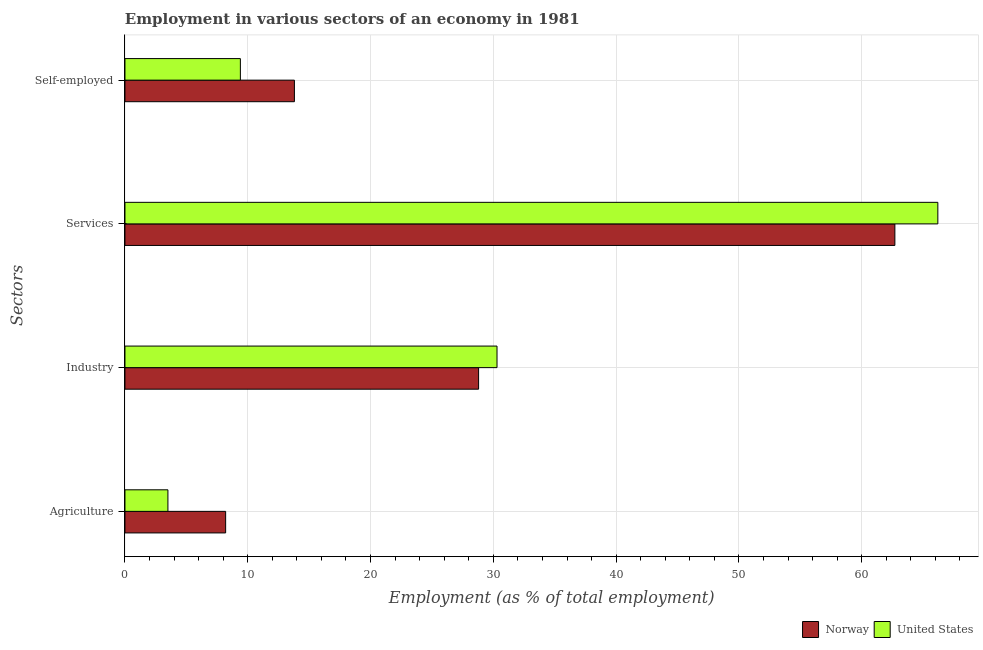How many different coloured bars are there?
Offer a terse response. 2. How many groups of bars are there?
Keep it short and to the point. 4. What is the label of the 4th group of bars from the top?
Keep it short and to the point. Agriculture. What is the percentage of workers in services in United States?
Give a very brief answer. 66.2. Across all countries, what is the maximum percentage of workers in services?
Keep it short and to the point. 66.2. Across all countries, what is the minimum percentage of workers in industry?
Give a very brief answer. 28.8. In which country was the percentage of workers in services minimum?
Offer a terse response. Norway. What is the total percentage of workers in industry in the graph?
Provide a short and direct response. 59.1. What is the difference between the percentage of self employed workers in United States and that in Norway?
Your answer should be compact. -4.4. What is the difference between the percentage of workers in industry in Norway and the percentage of self employed workers in United States?
Provide a short and direct response. 19.4. What is the average percentage of workers in agriculture per country?
Your response must be concise. 5.85. What is the difference between the percentage of self employed workers and percentage of workers in agriculture in Norway?
Keep it short and to the point. 5.6. In how many countries, is the percentage of workers in services greater than 6 %?
Offer a terse response. 2. What is the ratio of the percentage of workers in services in Norway to that in United States?
Make the answer very short. 0.95. Is the difference between the percentage of workers in services in Norway and United States greater than the difference between the percentage of workers in agriculture in Norway and United States?
Keep it short and to the point. No. What is the difference between the highest and the second highest percentage of self employed workers?
Offer a terse response. 4.4. Is it the case that in every country, the sum of the percentage of workers in agriculture and percentage of self employed workers is greater than the sum of percentage of workers in industry and percentage of workers in services?
Provide a succinct answer. Yes. Are all the bars in the graph horizontal?
Your response must be concise. Yes. How many countries are there in the graph?
Your answer should be very brief. 2. What is the difference between two consecutive major ticks on the X-axis?
Ensure brevity in your answer.  10. Are the values on the major ticks of X-axis written in scientific E-notation?
Ensure brevity in your answer.  No. Does the graph contain grids?
Ensure brevity in your answer.  Yes. How are the legend labels stacked?
Your response must be concise. Horizontal. What is the title of the graph?
Provide a short and direct response. Employment in various sectors of an economy in 1981. Does "Mauritania" appear as one of the legend labels in the graph?
Keep it short and to the point. No. What is the label or title of the X-axis?
Make the answer very short. Employment (as % of total employment). What is the label or title of the Y-axis?
Give a very brief answer. Sectors. What is the Employment (as % of total employment) of Norway in Agriculture?
Give a very brief answer. 8.2. What is the Employment (as % of total employment) of Norway in Industry?
Your response must be concise. 28.8. What is the Employment (as % of total employment) of United States in Industry?
Your answer should be compact. 30.3. What is the Employment (as % of total employment) of Norway in Services?
Offer a terse response. 62.7. What is the Employment (as % of total employment) of United States in Services?
Make the answer very short. 66.2. What is the Employment (as % of total employment) in Norway in Self-employed?
Give a very brief answer. 13.8. What is the Employment (as % of total employment) in United States in Self-employed?
Give a very brief answer. 9.4. Across all Sectors, what is the maximum Employment (as % of total employment) in Norway?
Make the answer very short. 62.7. Across all Sectors, what is the maximum Employment (as % of total employment) in United States?
Your answer should be compact. 66.2. Across all Sectors, what is the minimum Employment (as % of total employment) of Norway?
Your response must be concise. 8.2. What is the total Employment (as % of total employment) in Norway in the graph?
Your answer should be very brief. 113.5. What is the total Employment (as % of total employment) of United States in the graph?
Offer a very short reply. 109.4. What is the difference between the Employment (as % of total employment) in Norway in Agriculture and that in Industry?
Ensure brevity in your answer.  -20.6. What is the difference between the Employment (as % of total employment) of United States in Agriculture and that in Industry?
Make the answer very short. -26.8. What is the difference between the Employment (as % of total employment) of Norway in Agriculture and that in Services?
Your response must be concise. -54.5. What is the difference between the Employment (as % of total employment) in United States in Agriculture and that in Services?
Make the answer very short. -62.7. What is the difference between the Employment (as % of total employment) in United States in Agriculture and that in Self-employed?
Provide a succinct answer. -5.9. What is the difference between the Employment (as % of total employment) of Norway in Industry and that in Services?
Make the answer very short. -33.9. What is the difference between the Employment (as % of total employment) in United States in Industry and that in Services?
Your answer should be compact. -35.9. What is the difference between the Employment (as % of total employment) in Norway in Industry and that in Self-employed?
Offer a very short reply. 15. What is the difference between the Employment (as % of total employment) in United States in Industry and that in Self-employed?
Ensure brevity in your answer.  20.9. What is the difference between the Employment (as % of total employment) of Norway in Services and that in Self-employed?
Keep it short and to the point. 48.9. What is the difference between the Employment (as % of total employment) in United States in Services and that in Self-employed?
Keep it short and to the point. 56.8. What is the difference between the Employment (as % of total employment) in Norway in Agriculture and the Employment (as % of total employment) in United States in Industry?
Provide a succinct answer. -22.1. What is the difference between the Employment (as % of total employment) of Norway in Agriculture and the Employment (as % of total employment) of United States in Services?
Your response must be concise. -58. What is the difference between the Employment (as % of total employment) of Norway in Industry and the Employment (as % of total employment) of United States in Services?
Your answer should be compact. -37.4. What is the difference between the Employment (as % of total employment) in Norway in Industry and the Employment (as % of total employment) in United States in Self-employed?
Provide a short and direct response. 19.4. What is the difference between the Employment (as % of total employment) in Norway in Services and the Employment (as % of total employment) in United States in Self-employed?
Keep it short and to the point. 53.3. What is the average Employment (as % of total employment) in Norway per Sectors?
Your answer should be very brief. 28.38. What is the average Employment (as % of total employment) in United States per Sectors?
Give a very brief answer. 27.35. What is the difference between the Employment (as % of total employment) in Norway and Employment (as % of total employment) in United States in Services?
Your answer should be compact. -3.5. What is the ratio of the Employment (as % of total employment) of Norway in Agriculture to that in Industry?
Offer a terse response. 0.28. What is the ratio of the Employment (as % of total employment) of United States in Agriculture to that in Industry?
Provide a short and direct response. 0.12. What is the ratio of the Employment (as % of total employment) in Norway in Agriculture to that in Services?
Ensure brevity in your answer.  0.13. What is the ratio of the Employment (as % of total employment) of United States in Agriculture to that in Services?
Offer a very short reply. 0.05. What is the ratio of the Employment (as % of total employment) in Norway in Agriculture to that in Self-employed?
Keep it short and to the point. 0.59. What is the ratio of the Employment (as % of total employment) of United States in Agriculture to that in Self-employed?
Offer a terse response. 0.37. What is the ratio of the Employment (as % of total employment) of Norway in Industry to that in Services?
Provide a succinct answer. 0.46. What is the ratio of the Employment (as % of total employment) of United States in Industry to that in Services?
Your answer should be very brief. 0.46. What is the ratio of the Employment (as % of total employment) of Norway in Industry to that in Self-employed?
Your response must be concise. 2.09. What is the ratio of the Employment (as % of total employment) in United States in Industry to that in Self-employed?
Provide a short and direct response. 3.22. What is the ratio of the Employment (as % of total employment) in Norway in Services to that in Self-employed?
Ensure brevity in your answer.  4.54. What is the ratio of the Employment (as % of total employment) of United States in Services to that in Self-employed?
Your answer should be compact. 7.04. What is the difference between the highest and the second highest Employment (as % of total employment) in Norway?
Keep it short and to the point. 33.9. What is the difference between the highest and the second highest Employment (as % of total employment) in United States?
Provide a short and direct response. 35.9. What is the difference between the highest and the lowest Employment (as % of total employment) in Norway?
Give a very brief answer. 54.5. What is the difference between the highest and the lowest Employment (as % of total employment) of United States?
Your response must be concise. 62.7. 